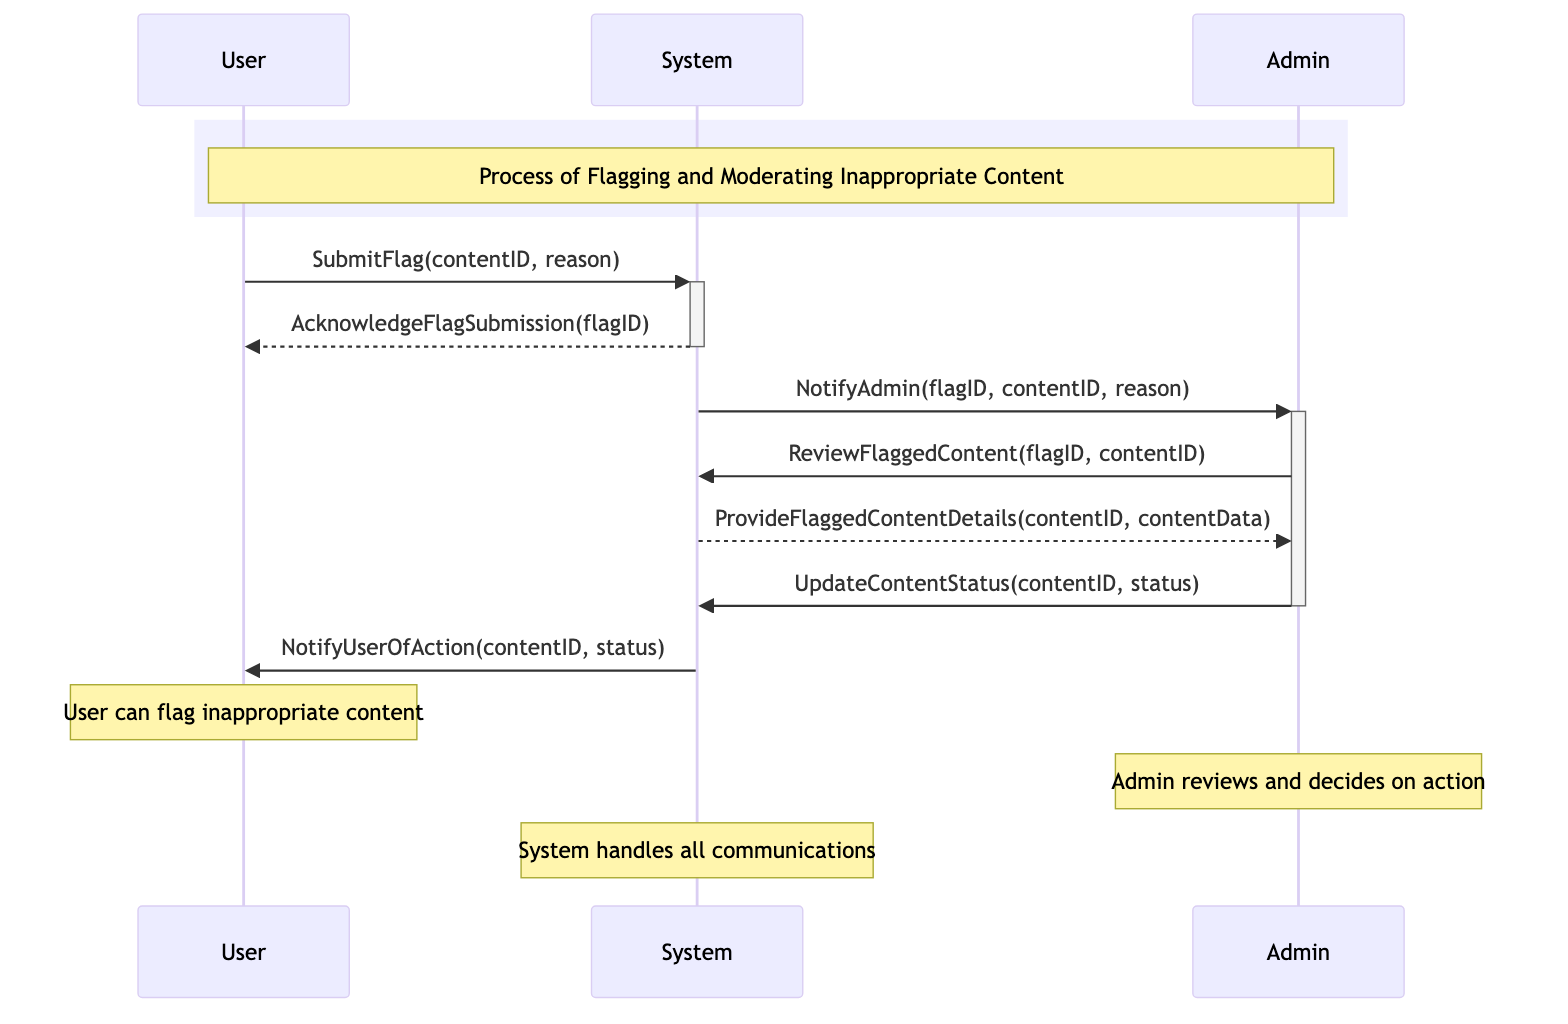What's the first action taken in the process? The first action is when the User submits a flag through the System by using the message "SubmitFlag(contentID, reason)." This is depicted at the beginning of the sequence.
Answer: SubmitFlag(contentID, reason) How many main actors are involved in the diagram? The diagram includes three main actors: User, Admin, and System. Each actor is represented in the sequence and contributes to the messaging process.
Answer: Three What message does the System send back to the User after a flag is submitted? After the User submits a flag, the System acknowledges the submission by sending the message "AcknowledgeFlagSubmission(flagID)." This indicates the System has received the flag.
Answer: AcknowledgeFlagSubmission(flagID) What does the Admin do after being notified of a flagged content? After receiving the notification from the System about the flagged content, the Admin proceeds to review the flagged content by sending the message "ReviewFlaggedContent(flagID, contentID)." This shows the Admin's action following the notification.
Answer: ReviewFlaggedContent(flagID, contentID) What is the final message sent to the User after the Admin updates content status? Once the Admin updates the status of the flagged content, the System sends a notification to the User with the message "NotifyUserOfAction(contentID, status)." This concludes the moderation process as the User is informed of the outcome.
Answer: NotifyUserOfAction(contentID, status) Why is the System vital in this sequence? The System serves as the intermediary that facilitates all communications between the User and Admin, handling the submission of flags, notifying Admins, and informing Users of the final actions taken. This centralized role is essential for the moderation process.
Answer: Centralized communication What procedural step follows the Admin reviewing flagged content? After the Admin reviews the flagged content, the next step is for the Admin to update the content status with the message "UpdateContentStatus(contentID, status)." This indicates a decision has been made regarding the flagged content.
Answer: UpdateContentStatus(contentID, status) What type of message does the Admin send to the System regarding the flagged content? The Admin sends a command to the System in the form of "UpdateContentStatus(contentID, status)" to indicate the decision made after reviewing the flagged content. This message type is an update.
Answer: UpdateContentStatus(contentID, status) 